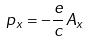Convert formula to latex. <formula><loc_0><loc_0><loc_500><loc_500>p _ { x } = - \frac { e } { c } A _ { x }</formula> 